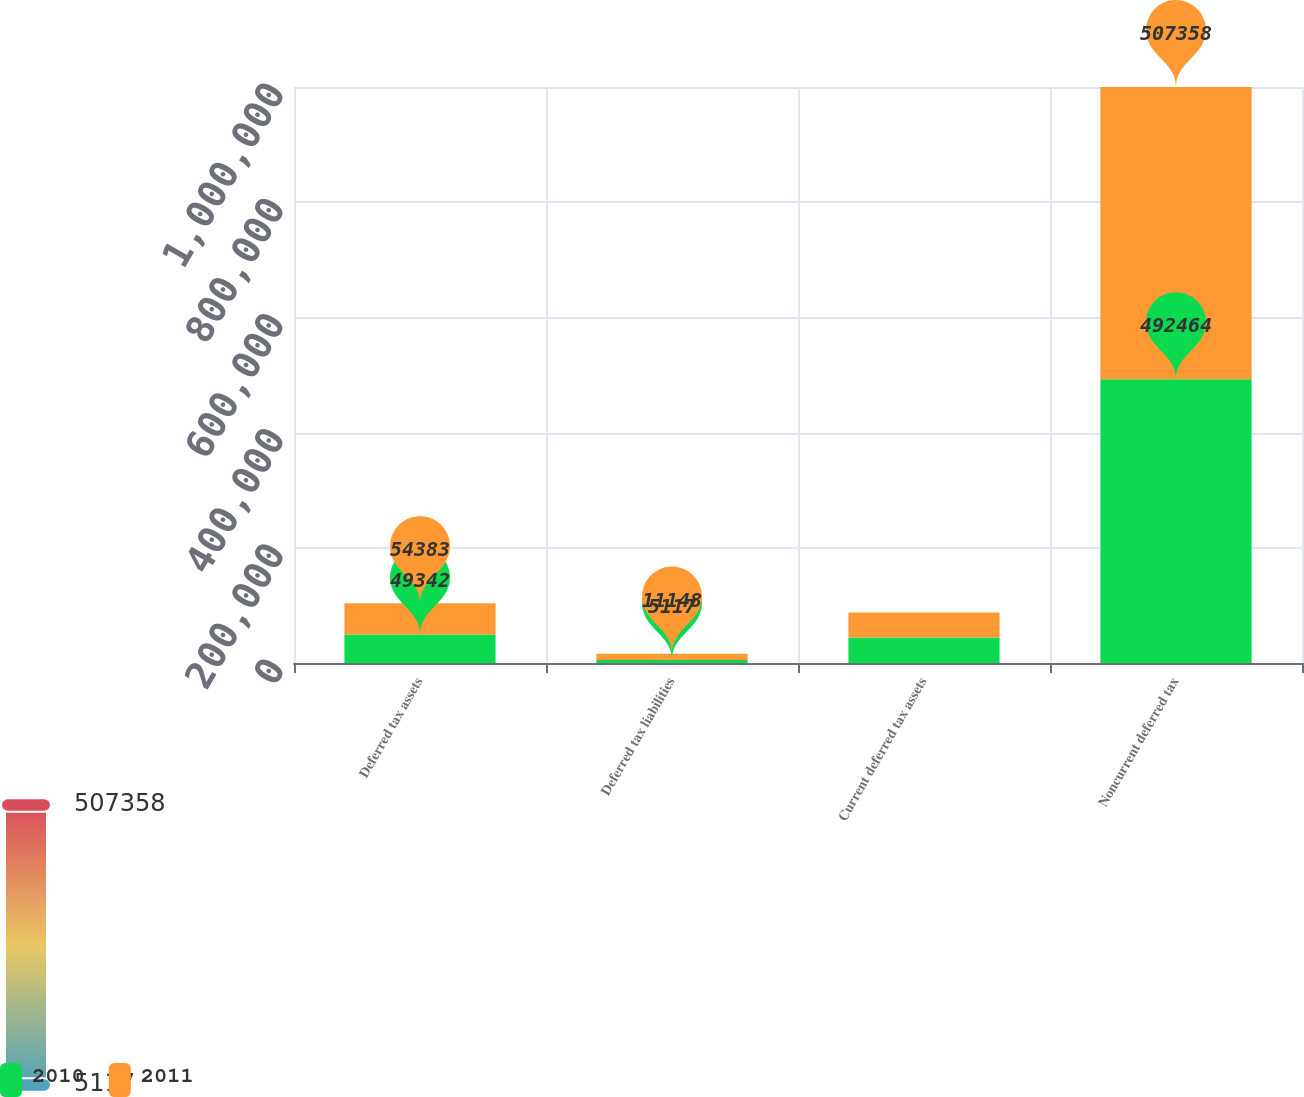Convert chart to OTSL. <chart><loc_0><loc_0><loc_500><loc_500><stacked_bar_chart><ecel><fcel>Deferred tax assets<fcel>Deferred tax liabilities<fcel>Current deferred tax assets<fcel>Noncurrent deferred tax<nl><fcel>2010<fcel>49342<fcel>5117<fcel>44225<fcel>492464<nl><fcel>2011<fcel>54383<fcel>11148<fcel>43235<fcel>507358<nl></chart> 